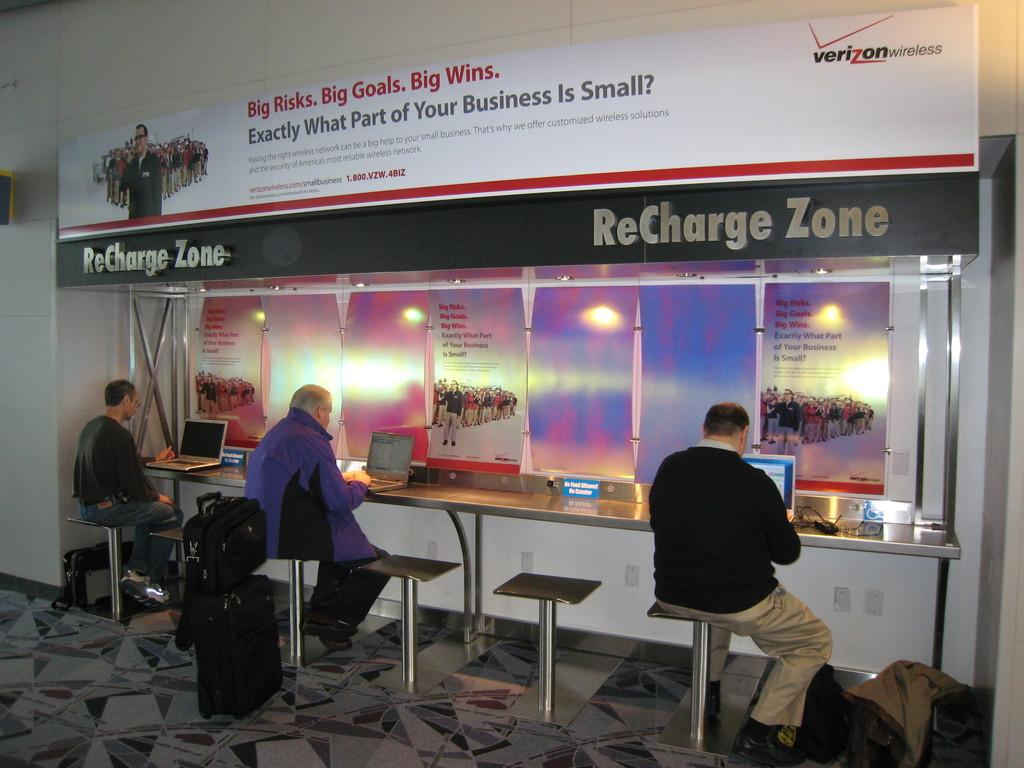Provide a one-sentence caption for the provided image. Three people sitting at a Verizon recharge zone with laptops. 